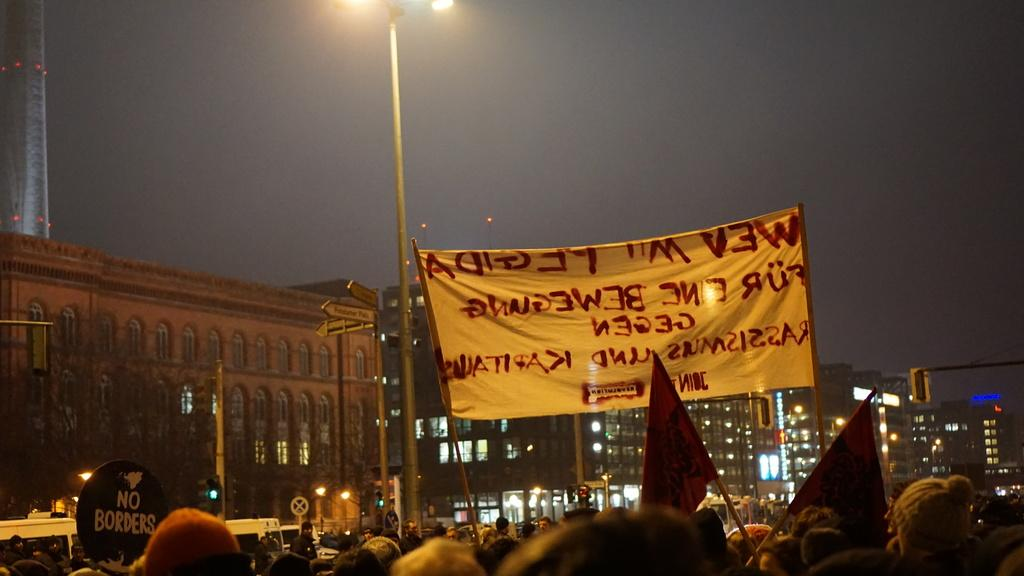What is the main subject of the image? There is a group of people standing on the ground. What can be seen in the background of the image? In the background, there are banners, buildings, pole lights, flags, the sky, and other objects. Can you describe the lighting in the image? Pole lights are present in the background, which suggests that the area is well-lit. How many trees can be seen in the image? There are no trees visible in the image. What type of stem is holding up the street in the image? There is no street or stem present in the image. 